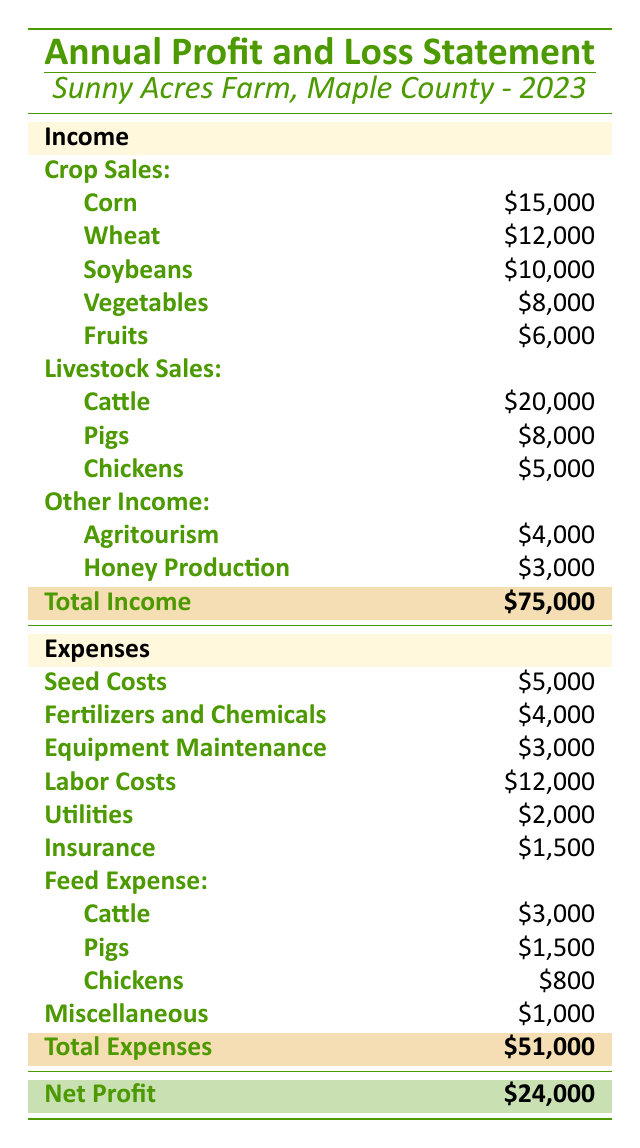What is the total income for Sunny Acres Farm in 2023? The total income is directly stated in the table under the Total Income section. It is listed as \$75,000.
Answer: \$75,000 What are the expenses related to livestock feed? The expenses related to livestock feed are categorized under Feed Expense, which lists \$3,000 for Cattle, \$1,500 for Pigs, and \$800 for Chickens. The total for livestock feed can also be calculated as 3000 + 1500 + 800 = \$5,300.
Answer: \$5,300 Is the net profit greater than \$20,000? The net profit is listed in the table as \$24,000, which is indeed greater than \$20,000.
Answer: Yes How much income does Sunny Acres Farm generate from Crop Sales? The income from Crop Sales can be found by summing the individual crop sales: \$15,000 (Corn) + \$12,000 (Wheat) + \$10,000 (Soybeans) + \$8,000 (Vegetables) + \$6,000 (Fruits) = \$51,000.
Answer: \$51,000 What percentage of the total income comes from Livestock Sales? To calculate the percentage, first sum the income from Livestock Sales: \$20,000 (Cattle) + \$8,000 (Pigs) + \$5,000 (Chickens) = \$33,000. Then, divide the Livestock Sales total by Total Income and multiply by 100: (33000 / 75000) * 100 = 44%.
Answer: 44% What is the total of Expenses and how does it compare to Total Income? The total expenses are stated as \$51,000 in the table. Comparing this to Total Income, which is \$75,000, means that expenses are lower than income, resulting in a profit.
Answer: Expenses are lower Calculate the total profit margin percentage for Sunny Acres Farm. The profit margin percentage is calculated as Net Profit divided by Total Income, then multiplied by 100: (24000 / 75000) * 100 = 32%.
Answer: 32% Which source of income contributes the least to the total income? Looking at the income sources, the least amount comes from Fruits, which is \$6,000. This can be identified directly from the Crop Sales section of the table.
Answer: Fruits If Sunny Acres Farm were to reduce Labor Costs by 10%, how much would that save? Labor Costs are listed as \$12,000. To find a 10% reduction, multiply by 0.10: 12000 * 0.10 = \$1,200. This would save the farm \$1,200 in costs.
Answer: \$1,200 What is the difference between Total Income and Total Expenses? The difference can be computed by subtracting Total Expenses from Total Income: \$75,000 (Total Income) - \$51,000 (Total Expenses) = \$24,000, which is also the Net Profit stated in the table.
Answer: \$24,000 How much does Sunny Acres Farm spend on Utilities compared to Insurance? Utilities cost \$2,000 and Insurance costs \$1,500. The Utilities expense is greater than Insurance by \$500. This can be determined by comparing those two figures directly.
Answer: Utilities are \$500 more 